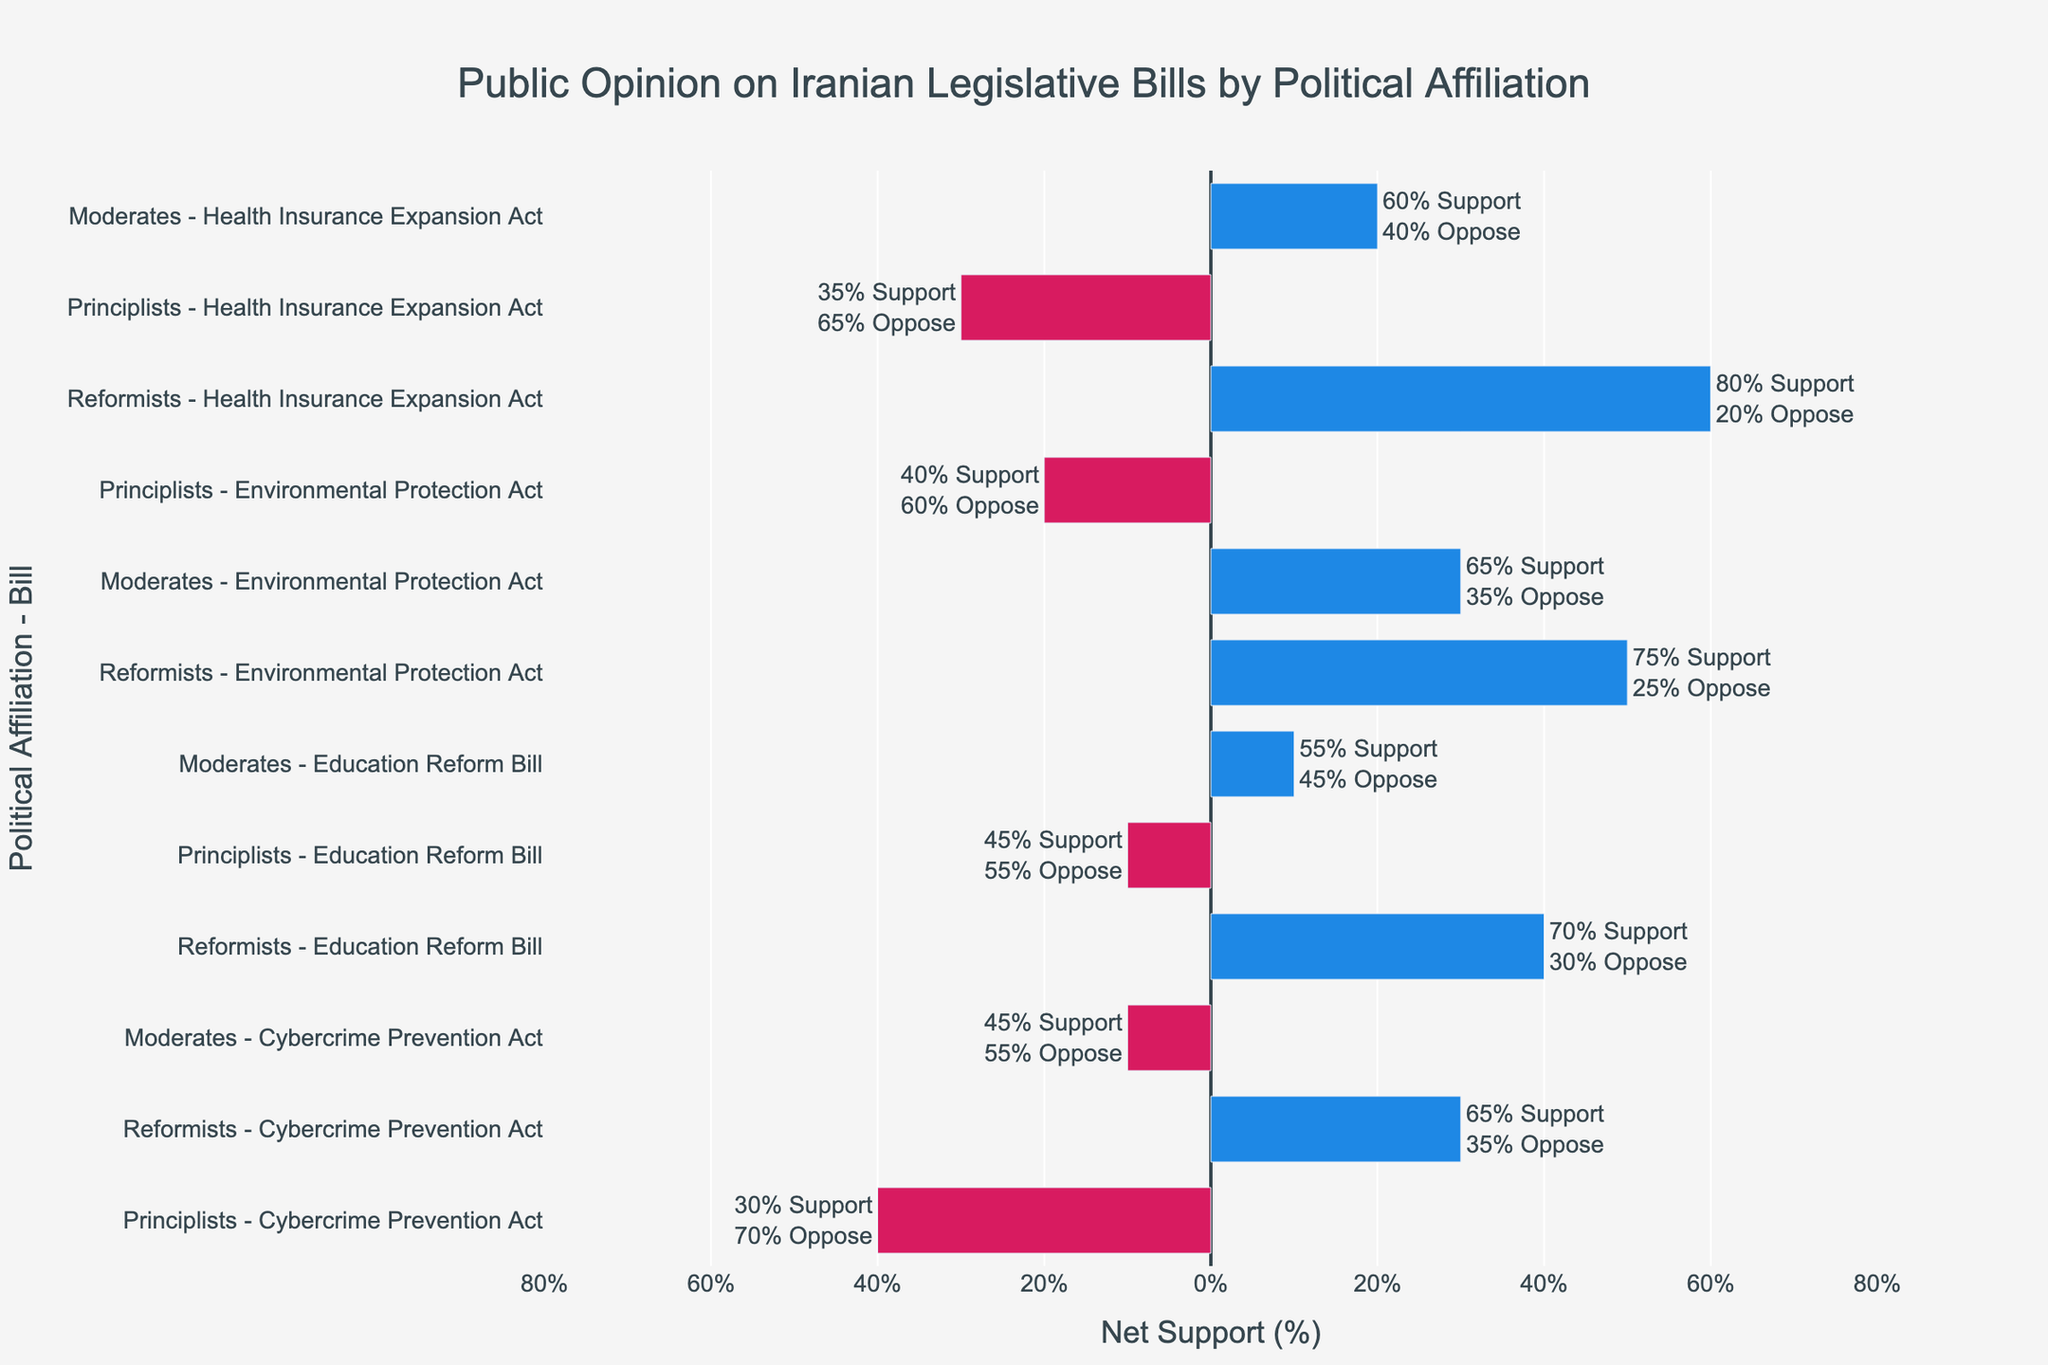Which political affiliation shows the highest support for the Health Insurance Expansion Act? The chart shows support levels for each political affiliation on the Health Insurance Expansion Act. The Reformists show the highest support, with a net support of 80%.
Answer: Reformists Which bill has the greatest difference in net support between Reformists and Principlists? To determine this, calculate the net support difference between Reformists and Principlists for each bill. The Cybercrime Prevention Act has the greatest difference, with 65% support from Reformists and 30% from Principlists, resulting in a difference of 35%.
Answer: Cybercrime Prevention Act How does the net support for the Education Reform Bill compare between Principlists and Moderates? The chart shows that Principlists have a net support of -10% (45% support minus 55% oppose) and Moderates have a net support of 10% (55% support minus 45% oppose) for the Education Reform Bill.
Answer: Moderates have higher net support For the Environmental Protection Act, which political affiliation has a neutral or negative net support? Looking at the net support for the Environmental Protection Act, Principlists have 40% support and 60% oppose, resulting in a negative net support of -20%.
Answer: Principlists Which bill do Moderates support the most, and what is their net support level? To find this, compare the support levels of Moderates for all bills. Moderates support the Health Insurance Expansion Act the most, with a net support of 20% (60% support minus 40% oppose).
Answer: Health Insurance Expansion Act, 20% Among the Reformists, which bill has the lowest support level, and what is the net support percentage? Comparing the net support levels for all bills among Reformists, the Cybercrime Prevention Act has the lowest support at 65%.
Answer: Cybercrime Prevention Act, 30% Which bill has the most divisive support between Reformists and Moderates? Calculate the absolute differences in net support between Reformists and Moderates for all bills. The Cybercrime Prevention Act shows the largest divisive support, with a difference of 20% (65% for Reformists vs 45% for Moderates).
Answer: Cybercrime Prevention Act What is the overall trend of Principlists' support across all bills? Observe the net support levels of Principlists for each bill, all of which are negative, indicating an overall trend of opposition.
Answer: Principlists generally oppose How does the average support for all bills compare between Reformists and Principlists? Calculate the average support for Reformists: (65+80+75+70)/4 = 72.5%. For Principlists: (30+45+40+35)/4 = 37.5%. Thus, Reformists have a much higher average support.
Answer: Reformists have higher average support Which political affiliation shows a more balanced perspective (closer to neutral net support) on the Cybercrime Prevention Act? Comparing net support levels, Reformists have 30% net support, Principlists have -40% net support, and Moderates have -10% net support. Moderates, with -10%, are closest to neutral.
Answer: Moderates 